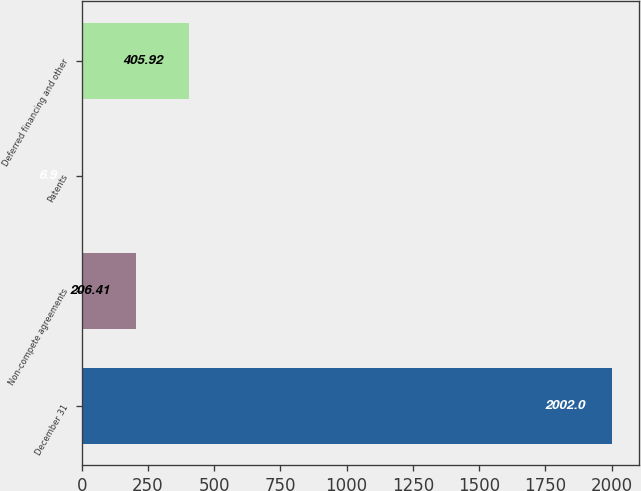Convert chart to OTSL. <chart><loc_0><loc_0><loc_500><loc_500><bar_chart><fcel>December 31<fcel>Non-compete agreements<fcel>Patents<fcel>Deferred financing and other<nl><fcel>2002<fcel>206.41<fcel>6.9<fcel>405.92<nl></chart> 